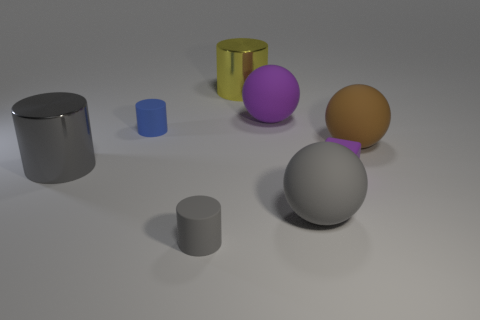What number of yellow metal cylinders have the same size as the blue matte cylinder?
Make the answer very short. 0. Is the shape of the large gray rubber object the same as the big brown object?
Your answer should be very brief. Yes. What color is the rubber cylinder behind the large cylinder in front of the big purple rubber object?
Make the answer very short. Blue. What size is the matte object that is both to the left of the large yellow cylinder and behind the large gray sphere?
Offer a very short reply. Small. Is there anything else that has the same color as the block?
Keep it short and to the point. Yes. What shape is the brown thing that is made of the same material as the tiny cube?
Offer a very short reply. Sphere. Do the brown object and the small object in front of the small purple rubber block have the same shape?
Ensure brevity in your answer.  No. There is a tiny cylinder behind the tiny cylinder in front of the tiny blue cylinder; what is its material?
Make the answer very short. Rubber. Is the number of big gray objects that are behind the large yellow metallic object the same as the number of cyan metallic cylinders?
Give a very brief answer. Yes. Are there any other things that are the same material as the small block?
Provide a short and direct response. Yes. 